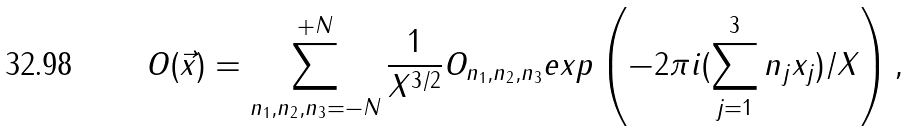<formula> <loc_0><loc_0><loc_500><loc_500>O ( { \vec { x } } ) = \sum _ { n _ { 1 } , n _ { 2 } , n _ { 3 } = - { N } } ^ { + { N } } \frac { 1 } { X ^ { 3 / 2 } } O _ { n _ { 1 } , n _ { 2 } , n _ { 3 } } e x p \left ( - 2 \pi i ( \sum _ { j = 1 } ^ { 3 } n _ { j } x _ { j } ) / X \right ) ,</formula> 